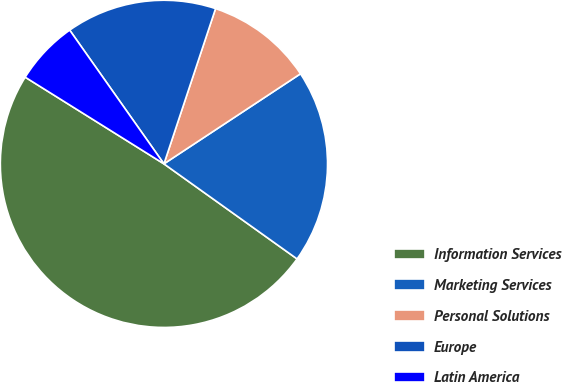<chart> <loc_0><loc_0><loc_500><loc_500><pie_chart><fcel>Information Services<fcel>Marketing Services<fcel>Personal Solutions<fcel>Europe<fcel>Latin America<nl><fcel>49.02%<fcel>19.15%<fcel>10.61%<fcel>14.88%<fcel>6.34%<nl></chart> 